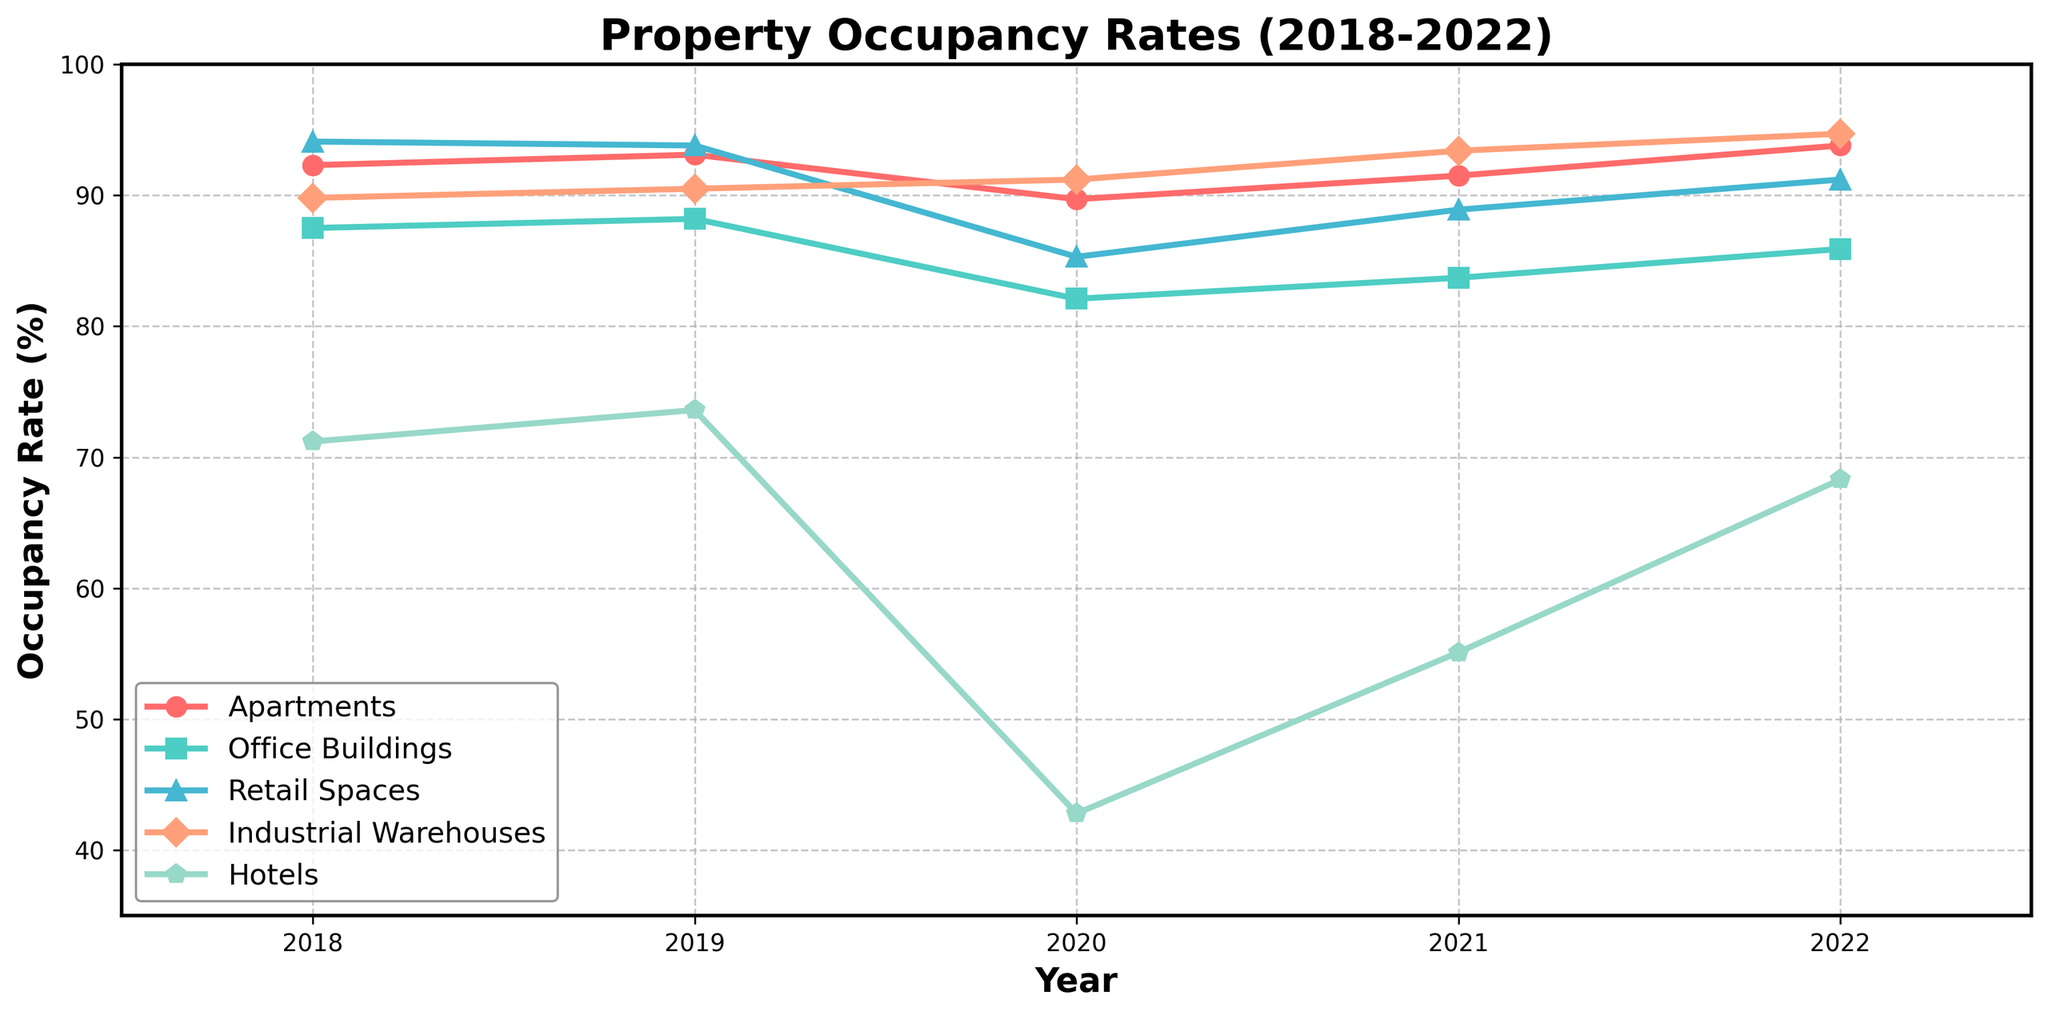What property type had the highest occupancy rate in 2018? Look at the 2018 values for all property types. Apartments have 92.3%, Office Buildings have 87.5%, Retail Spaces have 94.1%, Industrial Warehouses have 89.8%, and Hotels have 71.2%. Retail Spaces have the highest at 94.1%
Answer: Retail Spaces Which property type saw the largest drop in occupancy rate from 2019 to 2020? Compare the difference between 2019 and 2020 for each property type. The drops are Apartments 3.4% (93.1%-89.7%), Office Buildings 6.1% (88.2%-82.1%), Retail Spaces 8.5% (93.8%-85.3%), Industrial Warehouses -0.7% (90.5%-91.2%), and Hotels 30.8% (73.6%-42.8%). Hotels have the largest drop at 30.8%
Answer: Hotels What was the average occupancy rate for Offices over the 5-year period? Sum the occupancy rates for Offices over the 5 years (87.5 + 88.2 + 82.1 + 83.7 + 85.9 = 427.4) and divide by 5 to get the average. 427.4/5 = 85.48%
Answer: 85.48% Did Industrial Warehouses occupancy rate increase each year from 2018 to 2022? Observe the occupancy rates for Industrial Warehouses each year: 2018 (89.8%), 2019 (90.5%), 2020 (91.2%), 2021 (93.4%), 2022 (94.7%). Each year shows an increase from the previous year
Answer: Yes Which property type had the lowest occupancy rate in 2020, and what was it? Check the 2020 values for all property types: Apartments 89.7%, Office Buildings 82.1%, Retail Spaces 85.3%, Industrial Warehouses 91.2%, Hotels 42.8%. Hotels had the lowest at 42.8%
Answer: Hotels, 42.8% By how much did Retail Spaces' occupancy rate improve from 2020 to 2022? Compare Retail Spaces' rates in 2020 (85.3%) and 2022 (91.2%). The difference is 91.2% - 85.3% = 5.9%
Answer: 5.9% What color represents Industrial Warehouses in the plot? Identify the color associated with the line moving from 89.8% to 94.7%, which is orange.
Answer: Orange In which year did Hotels begin to show a recovery in their occupancy rate, and what was the rate? Look at the rates for Hotels across the years: 2018 (71.2%), 2019 (73.6%), 2020 (42.8%), 2021 (55.1%), 2022 (68.3%). The recovery starts in 2021, with the rate at 55.1%.
Answer: 2021, 55.1% 